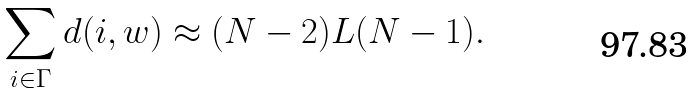Convert formula to latex. <formula><loc_0><loc_0><loc_500><loc_500>\sum _ { i \in \Gamma } d ( i , w ) \approx ( N - 2 ) L ( N - 1 ) .</formula> 